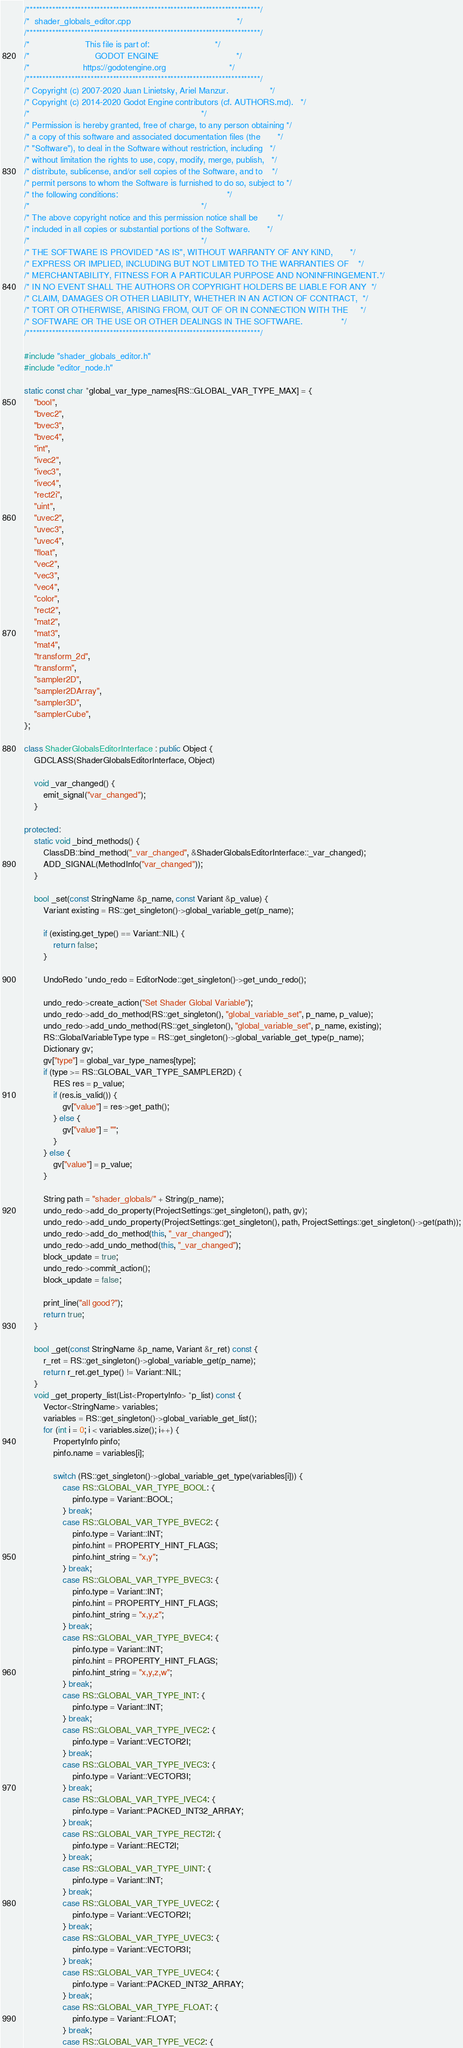<code> <loc_0><loc_0><loc_500><loc_500><_C++_>/*************************************************************************/
/*  shader_globals_editor.cpp                                            */
/*************************************************************************/
/*                       This file is part of:                           */
/*                           GODOT ENGINE                                */
/*                      https://godotengine.org                          */
/*************************************************************************/
/* Copyright (c) 2007-2020 Juan Linietsky, Ariel Manzur.                 */
/* Copyright (c) 2014-2020 Godot Engine contributors (cf. AUTHORS.md).   */
/*                                                                       */
/* Permission is hereby granted, free of charge, to any person obtaining */
/* a copy of this software and associated documentation files (the       */
/* "Software"), to deal in the Software without restriction, including   */
/* without limitation the rights to use, copy, modify, merge, publish,   */
/* distribute, sublicense, and/or sell copies of the Software, and to    */
/* permit persons to whom the Software is furnished to do so, subject to */
/* the following conditions:                                             */
/*                                                                       */
/* The above copyright notice and this permission notice shall be        */
/* included in all copies or substantial portions of the Software.       */
/*                                                                       */
/* THE SOFTWARE IS PROVIDED "AS IS", WITHOUT WARRANTY OF ANY KIND,       */
/* EXPRESS OR IMPLIED, INCLUDING BUT NOT LIMITED TO THE WARRANTIES OF    */
/* MERCHANTABILITY, FITNESS FOR A PARTICULAR PURPOSE AND NONINFRINGEMENT.*/
/* IN NO EVENT SHALL THE AUTHORS OR COPYRIGHT HOLDERS BE LIABLE FOR ANY  */
/* CLAIM, DAMAGES OR OTHER LIABILITY, WHETHER IN AN ACTION OF CONTRACT,  */
/* TORT OR OTHERWISE, ARISING FROM, OUT OF OR IN CONNECTION WITH THE     */
/* SOFTWARE OR THE USE OR OTHER DEALINGS IN THE SOFTWARE.                */
/*************************************************************************/

#include "shader_globals_editor.h"
#include "editor_node.h"

static const char *global_var_type_names[RS::GLOBAL_VAR_TYPE_MAX] = {
	"bool",
	"bvec2",
	"bvec3",
	"bvec4",
	"int",
	"ivec2",
	"ivec3",
	"ivec4",
	"rect2i",
	"uint",
	"uvec2",
	"uvec3",
	"uvec4",
	"float",
	"vec2",
	"vec3",
	"vec4",
	"color",
	"rect2",
	"mat2",
	"mat3",
	"mat4",
	"transform_2d",
	"transform",
	"sampler2D",
	"sampler2DArray",
	"sampler3D",
	"samplerCube",
};

class ShaderGlobalsEditorInterface : public Object {
	GDCLASS(ShaderGlobalsEditorInterface, Object)

	void _var_changed() {
		emit_signal("var_changed");
	}

protected:
	static void _bind_methods() {
		ClassDB::bind_method("_var_changed", &ShaderGlobalsEditorInterface::_var_changed);
		ADD_SIGNAL(MethodInfo("var_changed"));
	}

	bool _set(const StringName &p_name, const Variant &p_value) {
		Variant existing = RS::get_singleton()->global_variable_get(p_name);

		if (existing.get_type() == Variant::NIL) {
			return false;
		}

		UndoRedo *undo_redo = EditorNode::get_singleton()->get_undo_redo();

		undo_redo->create_action("Set Shader Global Variable");
		undo_redo->add_do_method(RS::get_singleton(), "global_variable_set", p_name, p_value);
		undo_redo->add_undo_method(RS::get_singleton(), "global_variable_set", p_name, existing);
		RS::GlobalVariableType type = RS::get_singleton()->global_variable_get_type(p_name);
		Dictionary gv;
		gv["type"] = global_var_type_names[type];
		if (type >= RS::GLOBAL_VAR_TYPE_SAMPLER2D) {
			RES res = p_value;
			if (res.is_valid()) {
				gv["value"] = res->get_path();
			} else {
				gv["value"] = "";
			}
		} else {
			gv["value"] = p_value;
		}

		String path = "shader_globals/" + String(p_name);
		undo_redo->add_do_property(ProjectSettings::get_singleton(), path, gv);
		undo_redo->add_undo_property(ProjectSettings::get_singleton(), path, ProjectSettings::get_singleton()->get(path));
		undo_redo->add_do_method(this, "_var_changed");
		undo_redo->add_undo_method(this, "_var_changed");
		block_update = true;
		undo_redo->commit_action();
		block_update = false;

		print_line("all good?");
		return true;
	}

	bool _get(const StringName &p_name, Variant &r_ret) const {
		r_ret = RS::get_singleton()->global_variable_get(p_name);
		return r_ret.get_type() != Variant::NIL;
	}
	void _get_property_list(List<PropertyInfo> *p_list) const {
		Vector<StringName> variables;
		variables = RS::get_singleton()->global_variable_get_list();
		for (int i = 0; i < variables.size(); i++) {
			PropertyInfo pinfo;
			pinfo.name = variables[i];

			switch (RS::get_singleton()->global_variable_get_type(variables[i])) {
				case RS::GLOBAL_VAR_TYPE_BOOL: {
					pinfo.type = Variant::BOOL;
				} break;
				case RS::GLOBAL_VAR_TYPE_BVEC2: {
					pinfo.type = Variant::INT;
					pinfo.hint = PROPERTY_HINT_FLAGS;
					pinfo.hint_string = "x,y";
				} break;
				case RS::GLOBAL_VAR_TYPE_BVEC3: {
					pinfo.type = Variant::INT;
					pinfo.hint = PROPERTY_HINT_FLAGS;
					pinfo.hint_string = "x,y,z";
				} break;
				case RS::GLOBAL_VAR_TYPE_BVEC4: {
					pinfo.type = Variant::INT;
					pinfo.hint = PROPERTY_HINT_FLAGS;
					pinfo.hint_string = "x,y,z,w";
				} break;
				case RS::GLOBAL_VAR_TYPE_INT: {
					pinfo.type = Variant::INT;
				} break;
				case RS::GLOBAL_VAR_TYPE_IVEC2: {
					pinfo.type = Variant::VECTOR2I;
				} break;
				case RS::GLOBAL_VAR_TYPE_IVEC3: {
					pinfo.type = Variant::VECTOR3I;
				} break;
				case RS::GLOBAL_VAR_TYPE_IVEC4: {
					pinfo.type = Variant::PACKED_INT32_ARRAY;
				} break;
				case RS::GLOBAL_VAR_TYPE_RECT2I: {
					pinfo.type = Variant::RECT2I;
				} break;
				case RS::GLOBAL_VAR_TYPE_UINT: {
					pinfo.type = Variant::INT;
				} break;
				case RS::GLOBAL_VAR_TYPE_UVEC2: {
					pinfo.type = Variant::VECTOR2I;
				} break;
				case RS::GLOBAL_VAR_TYPE_UVEC3: {
					pinfo.type = Variant::VECTOR3I;
				} break;
				case RS::GLOBAL_VAR_TYPE_UVEC4: {
					pinfo.type = Variant::PACKED_INT32_ARRAY;
				} break;
				case RS::GLOBAL_VAR_TYPE_FLOAT: {
					pinfo.type = Variant::FLOAT;
				} break;
				case RS::GLOBAL_VAR_TYPE_VEC2: {</code> 